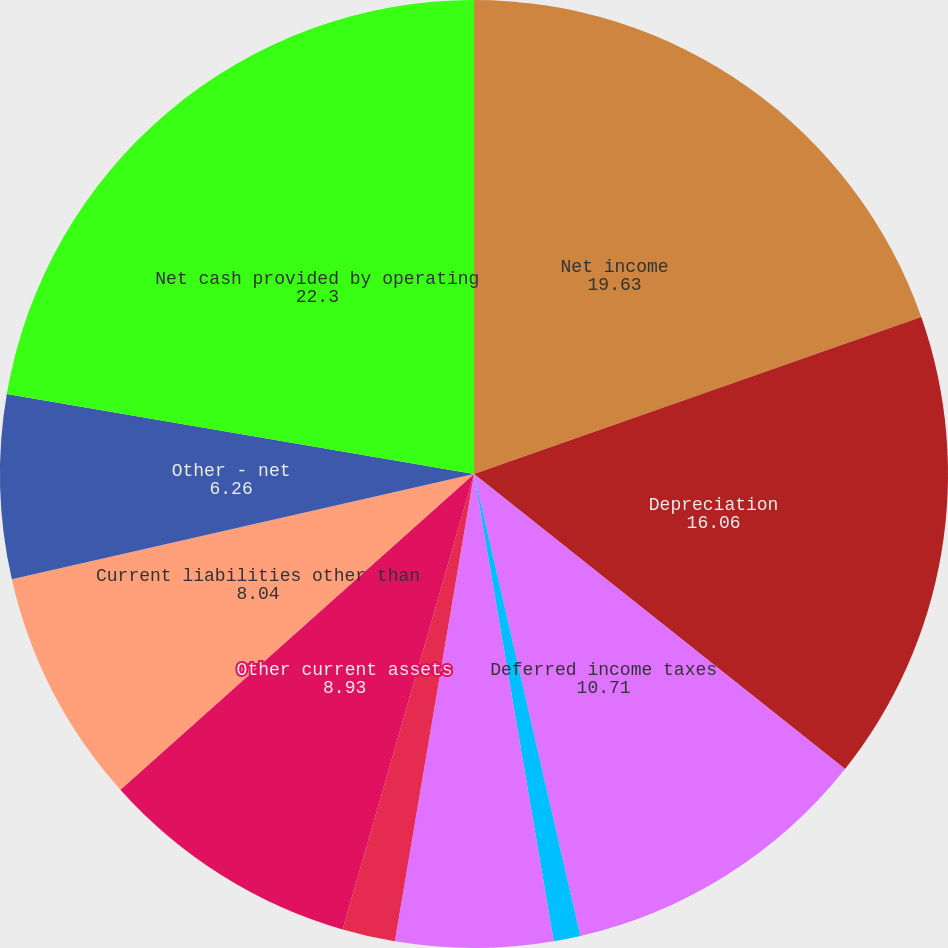<chart> <loc_0><loc_0><loc_500><loc_500><pie_chart><fcel>Net income<fcel>Depreciation<fcel>Deferred income taxes<fcel>Gains and losses on properties<fcel>Accounts receivable<fcel>Materials and supplies<fcel>Other current assets<fcel>Current liabilities other than<fcel>Other - net<fcel>Net cash provided by operating<nl><fcel>19.63%<fcel>16.06%<fcel>10.71%<fcel>0.91%<fcel>5.36%<fcel>1.8%<fcel>8.93%<fcel>8.04%<fcel>6.26%<fcel>22.3%<nl></chart> 